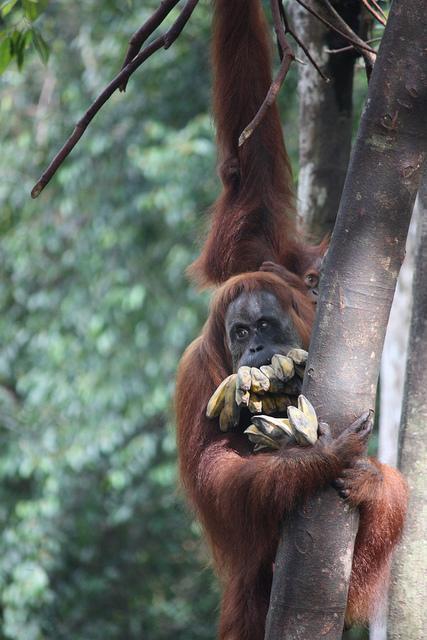What kind of fruit does the orangutan have in its mouth?
From the following four choices, select the correct answer to address the question.
Options: Watermelon, bananas, apples, oranges. Bananas. 